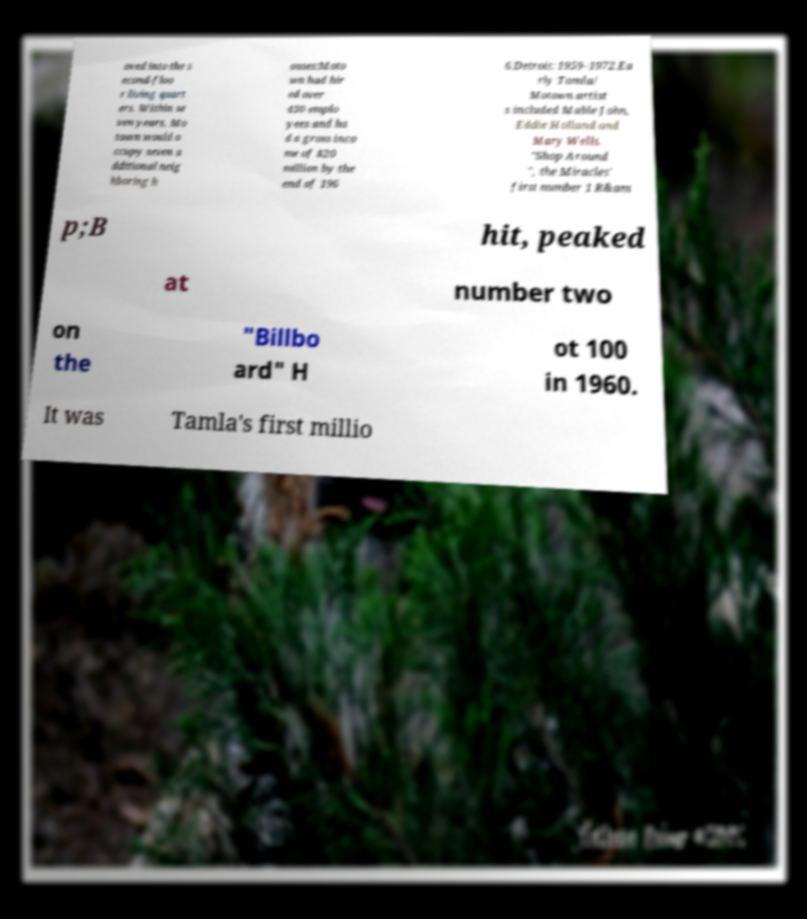Please identify and transcribe the text found in this image. oved into the s econd-floo r living quart ers. Within se ven years, Mo town would o ccupy seven a dditional neig hboring h ouses:Moto wn had hir ed over 450 emplo yees and ha d a gross inco me of $20 million by the end of 196 6.Detroit: 1959–1972.Ea rly Tamla/ Motown artist s included Mable John, Eddie Holland and Mary Wells. "Shop Around ", the Miracles' first number 1 R&am p;B hit, peaked at number two on the "Billbo ard" H ot 100 in 1960. It was Tamla's first millio 